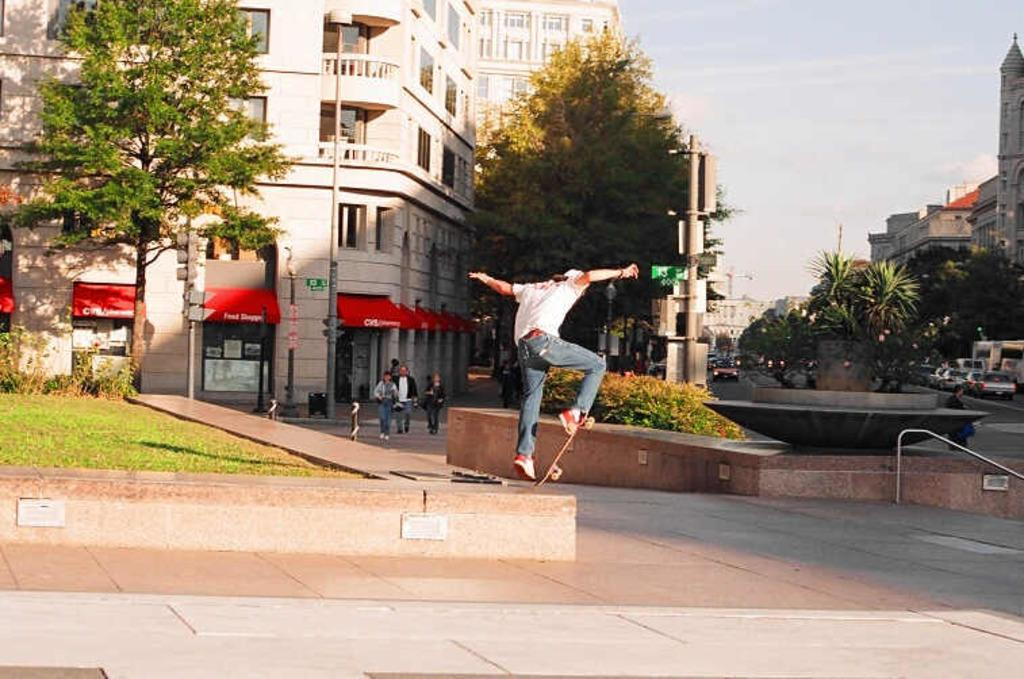How many people are in the image? There are people in the image, but the exact number is not specified. What type of structures can be seen in the image? There are buildings in the image. What type of vegetation is present in the image? There are trees and plants in the image. What type of man-made objects can be seen in the image? There are poles and boards in the image. What type of transportation is visible in the image? There are vehicles in the image. What type of surface is visible in the image? There is ground visible in the image. What part of the natural environment is visible in the image? The sky is visible in the image. What type of cup is being used to water the plants in the image? There is no cup visible in the image; plants are present, but no watering is depicted. 